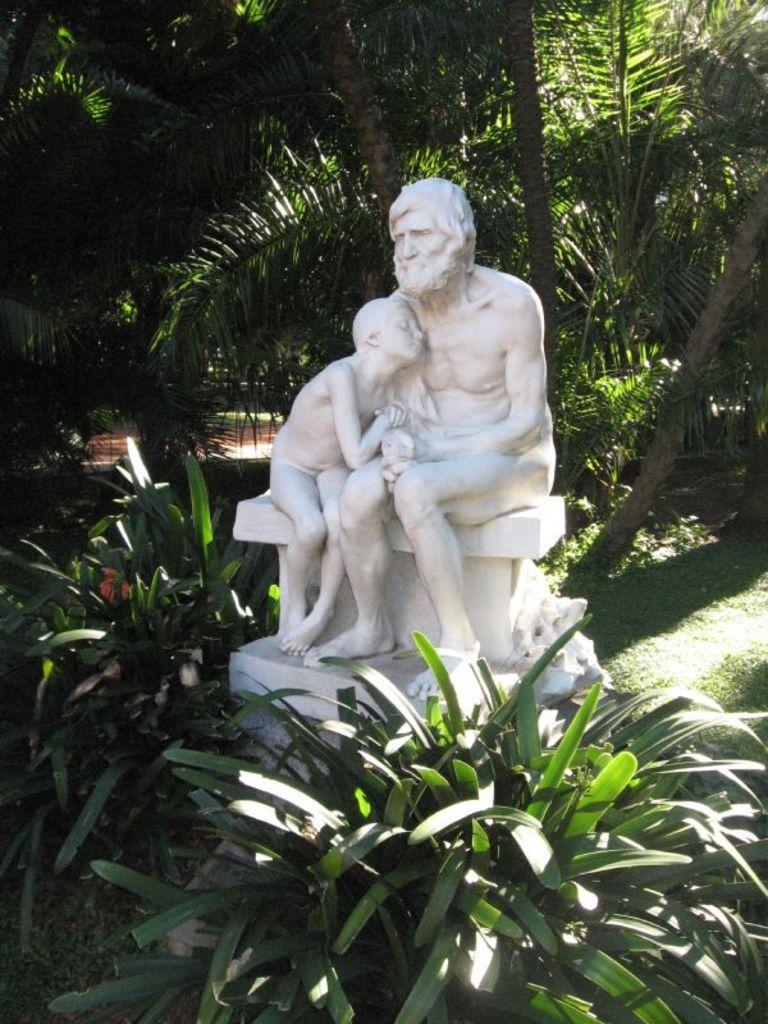Please provide a concise description of this image. In this image there is a statue of the man who is sitting on the wall. In the background there are trees. At the bottom there are plants near the statue. 